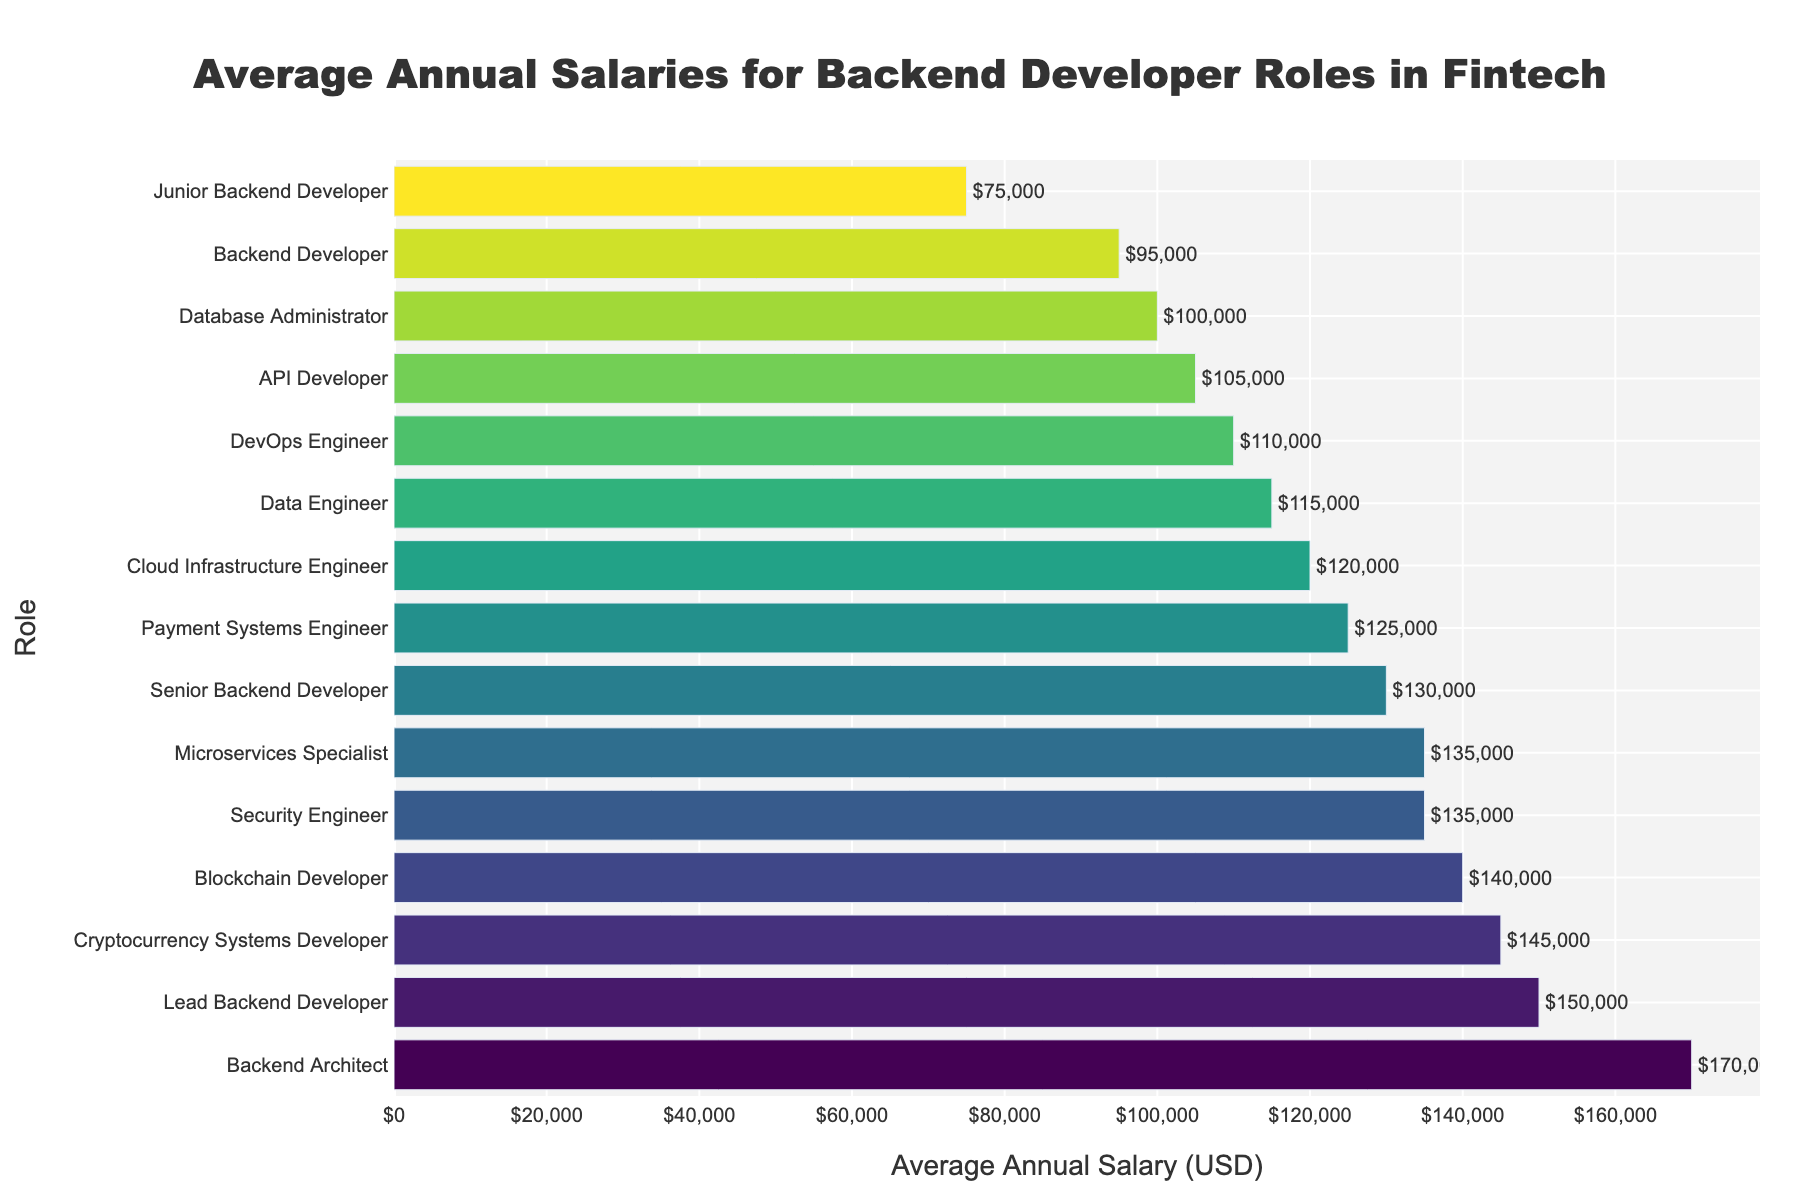What is the average annual salary of a Lead Backend Developer? The figure shows different backend developer roles with their associated salaries. Find the bar labeled "Lead Backend Developer" to see its corresponding salary.
Answer: $150,000 Which role has the highest average annual salary? Sort the bars from top to bottom and find the highest value. The role with the highest bar is the Backend Architect.
Answer: Backend Architect What is the difference in average annual salary between a Blockchain Developer and a Data Engineer? Find the average annual salary of the Blockchain Developer ($140,000) and the Data Engineer ($115,000). Subtract the Data Engineer's salary from the Blockchain Developer's salary: $140,000 - $115,000 = $25,000.
Answer: $25,000 How many roles have an average annual salary of $130,000 or more? Count the number of roles with bars that extend to the value of $130,000 or more. The roles are Senior Backend Developer, Lead Backend Developer, Backend Architect, Blockchain Developer, Cryptocurrency Systems Developer, and Security Engineer.
Answer: 6 Which roles have higher average annual salaries than a DevOps Engineer? Find the DevOps Engineer's salary ($110,000) on the chart and see which roles have longer bars (greater salaries) than this amount. The roles are Cloud Infrastructure Engineer, Blockchain Developer, Cryptocurrency Systems Developer, Payment Systems Engineer, Security Engineer, Microservices Specialist, Senior Backend Developer, Lead Backend Developer, and Backend Architect.
Answer: 9 roles What is the combined average annual salary of an API Developer and a Database Administrator? Find the average annual salaries of the API Developer ($105,000) and the Database Administrator ($100,000). Sum these values: $105,000 + $100,000 = $205,000.
Answer: $205,000 Is the average annual salary of a Microservices Specialist higher than that of a Security Engineer? Compare the lengths of the bars for both roles. Microservices Specialist has an average annual salary of $135,000, which is equal to the Security Engineer's.
Answer: No What is the visual difference in height between the bar for Cloud Infrastructure Engineer and that for Payment Systems Engineer? Observe the relative heights (lengths) of the bars. Cloud Infrastructure Engineer has a bar extending to $120,000, and Payment Systems Engineer extends to $125,000. The visual difference in height can be seen as the Payment Systems Engineer’s bar being slightly longer.
Answer: Payment Systems Engineer is slightly longer Which role has the shortest average annual salary and what is that amount? Find the role with the shortest bar on the chart. The role is Junior Backend Developer, and the average annual salary is $75,000.
Answer: Junior Backend Developer, $75,000 